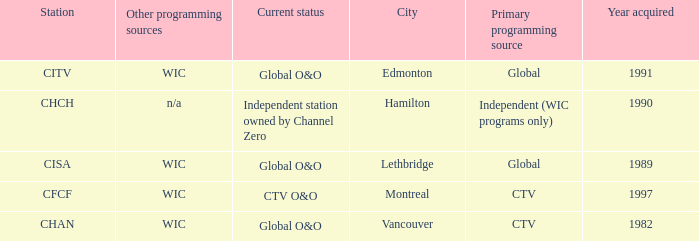Where is citv located Edmonton. 